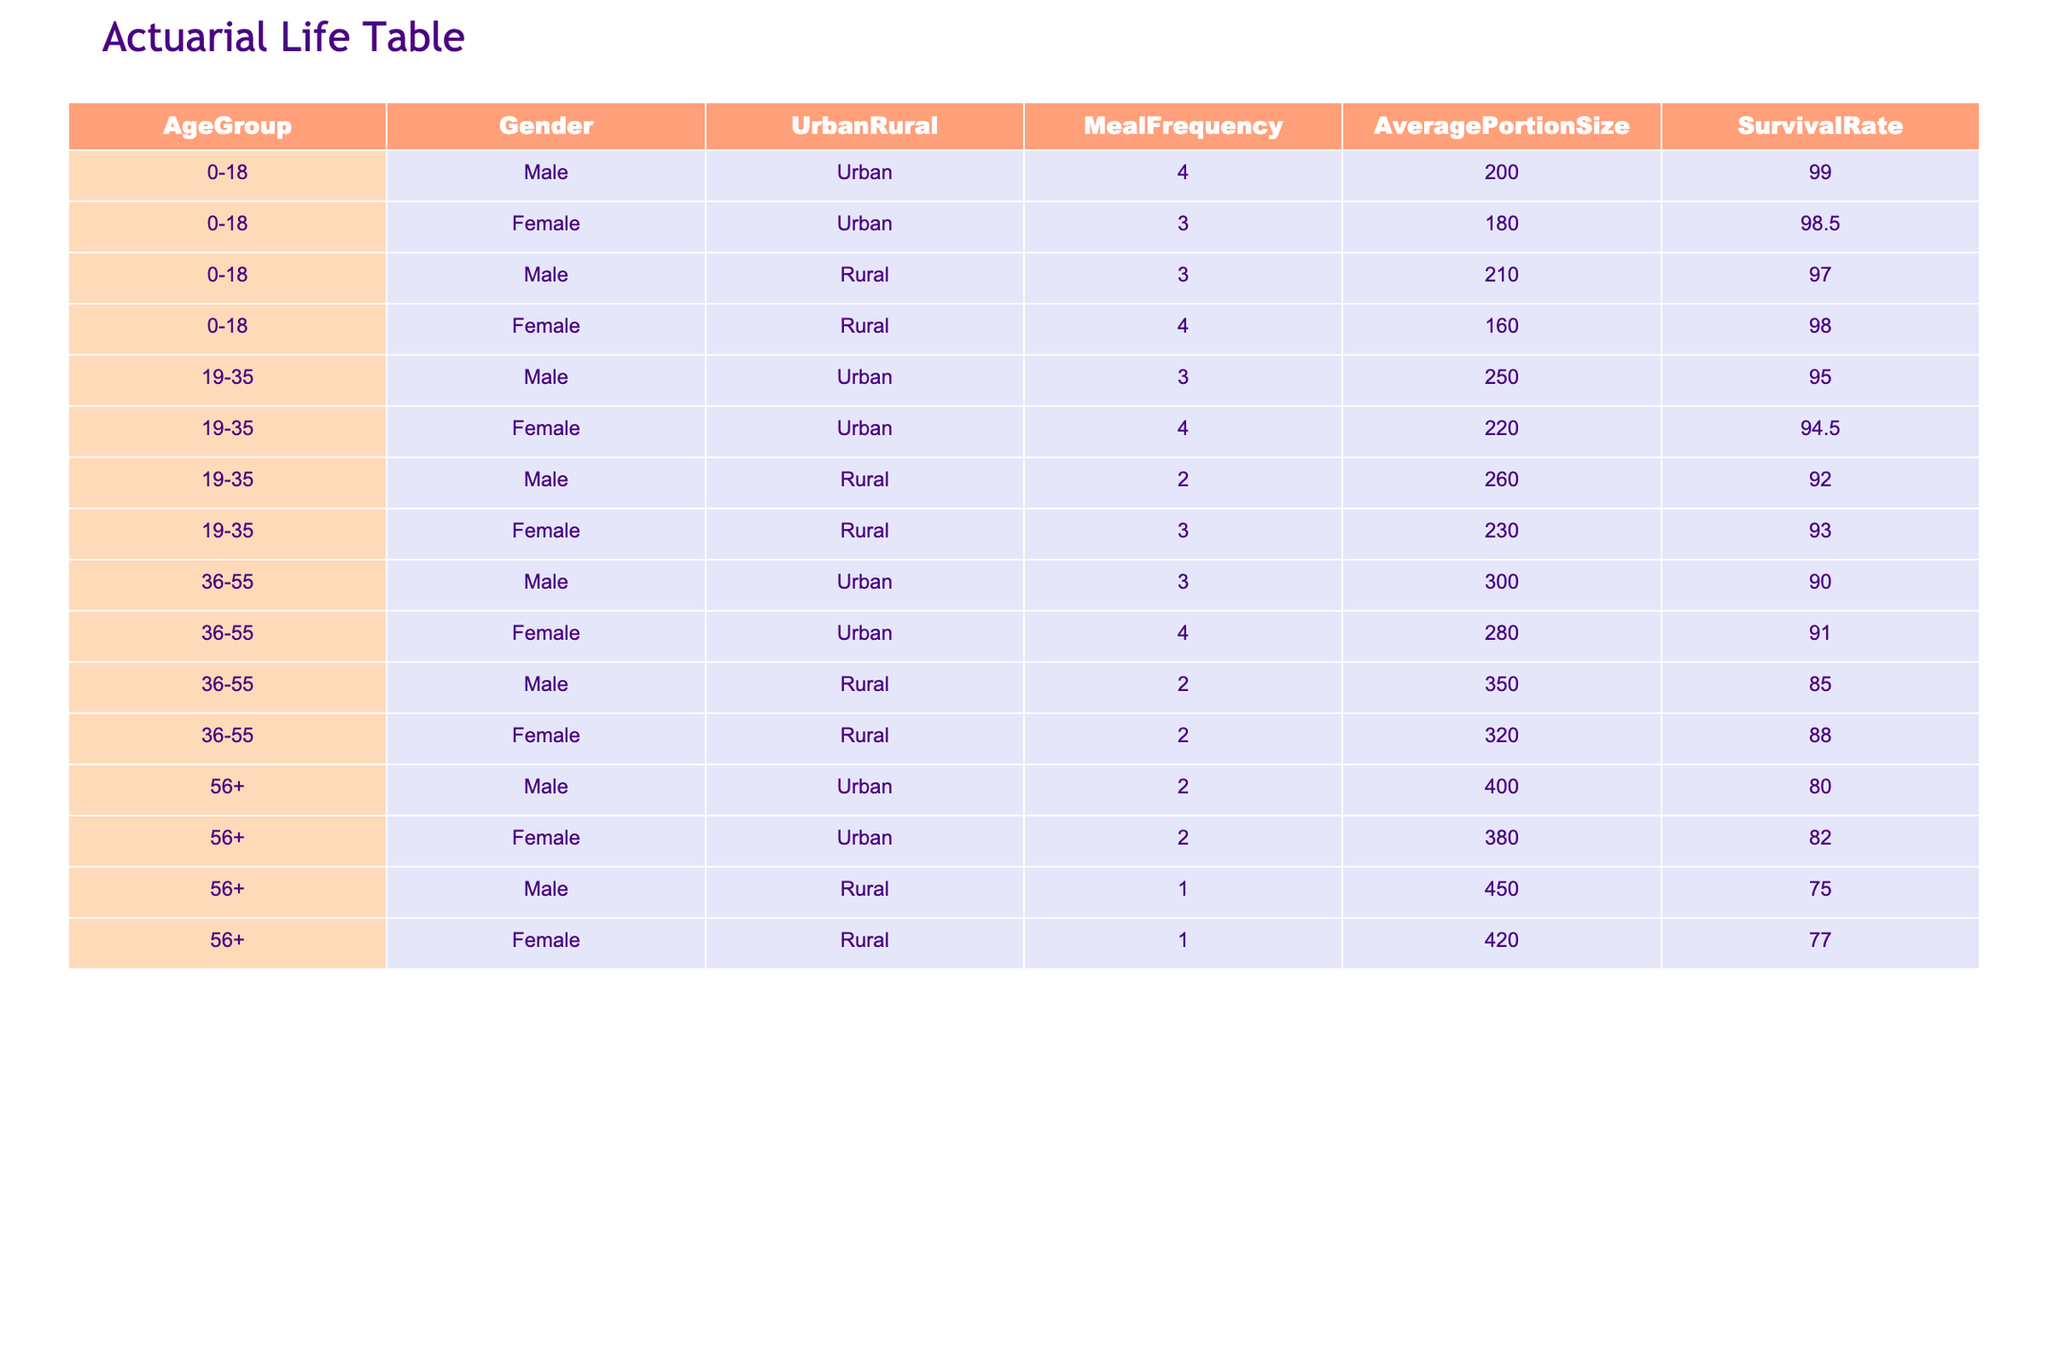What is the survival rate for males aged 0-18 living in urban areas? From the table, the survival rate for males aged 0-18 in urban areas is directly listed as 99.0.
Answer: 99.0 What is the average portion size for females aged 19-35 living in rural areas? The average portion size for females aged 19-35 in rural areas is listed as 230.
Answer: 230 Do urban males aged 36-55 have a higher average portion size than rural males in the same age group? Urban males aged 36-55 have an average portion size of 300, while rural males have an average portion size of 350. Therefore, rural males have a higher portion size.
Answer: No What is the survival rate for the oldest males in urban areas compared to the oldest females? The survival rate for oldest males (56+) in urban areas is 80.0, while for oldest females, it is 82.0. The males have a lower survival rate compared to the females.
Answer: Males have a lower survival rate How does the survival rate of rural females aged 36-55 compare to rural males in the same age group? The survival rate for rural females aged 36-55 is 88.0, and for rural males, it is 85.0. Females have a higher survival rate than males by 3.0.
Answer: Females have a higher survival rate What is the total difference in survival rates between urban males aged 19-35 and rural males in the same age group? The survival rate for urban males aged 19-35 is 95.0, while for rural males in the same age group, it is 92.0. The difference is 95.0 - 92.0 = 3.0.
Answer: 3.0 Are all demographic groups with a meal frequency of 4 associated with survival rates of 95 or above? The table shows females aged 0-18 (survival rate 98.5), urban females aged 19-35 (survival rate 94.5), and urban females aged 36-55 (survival rate 91.0) with meal frequency of 4, indicating that not all are above 95.
Answer: No What is the difference in survival rates between urban males and females aged 56+? For urban males aged 56+, the survival rate is 80.0 and for urban females, it is 82.0. The difference is 82.0 - 80.0 = 2.0.
Answer: 2.0 Which group has the lowest survival rate, and what is it? The lowest survival rate is for rural males aged 56+ at 75.0. This is the lowest value in the entire table.
Answer: 75.0 